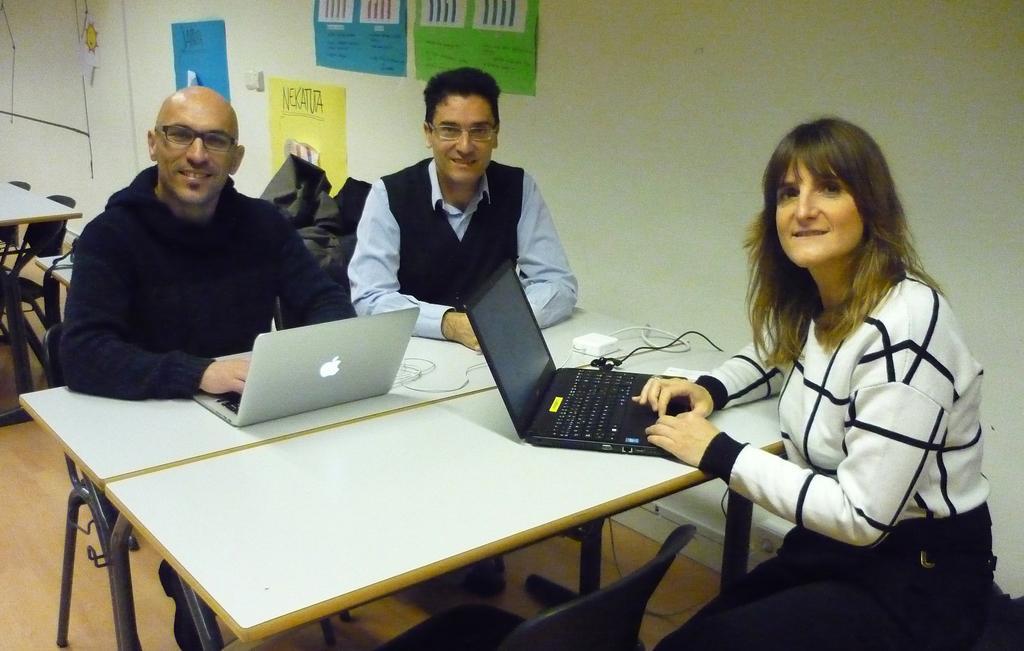Can you describe this image briefly? in this image i can see three persons sitting on the chair. Right side a woman wearing a black color jeans and white color top she kept kept her hand on system. A person wearing a blue color jacket kept on his with white color system. And there is another person sat beside him, he is wearing a spectacles and back side of him there a wall ,on the wall there are some papers attached to the wall an d left corner there is a table and there are some chairs. 